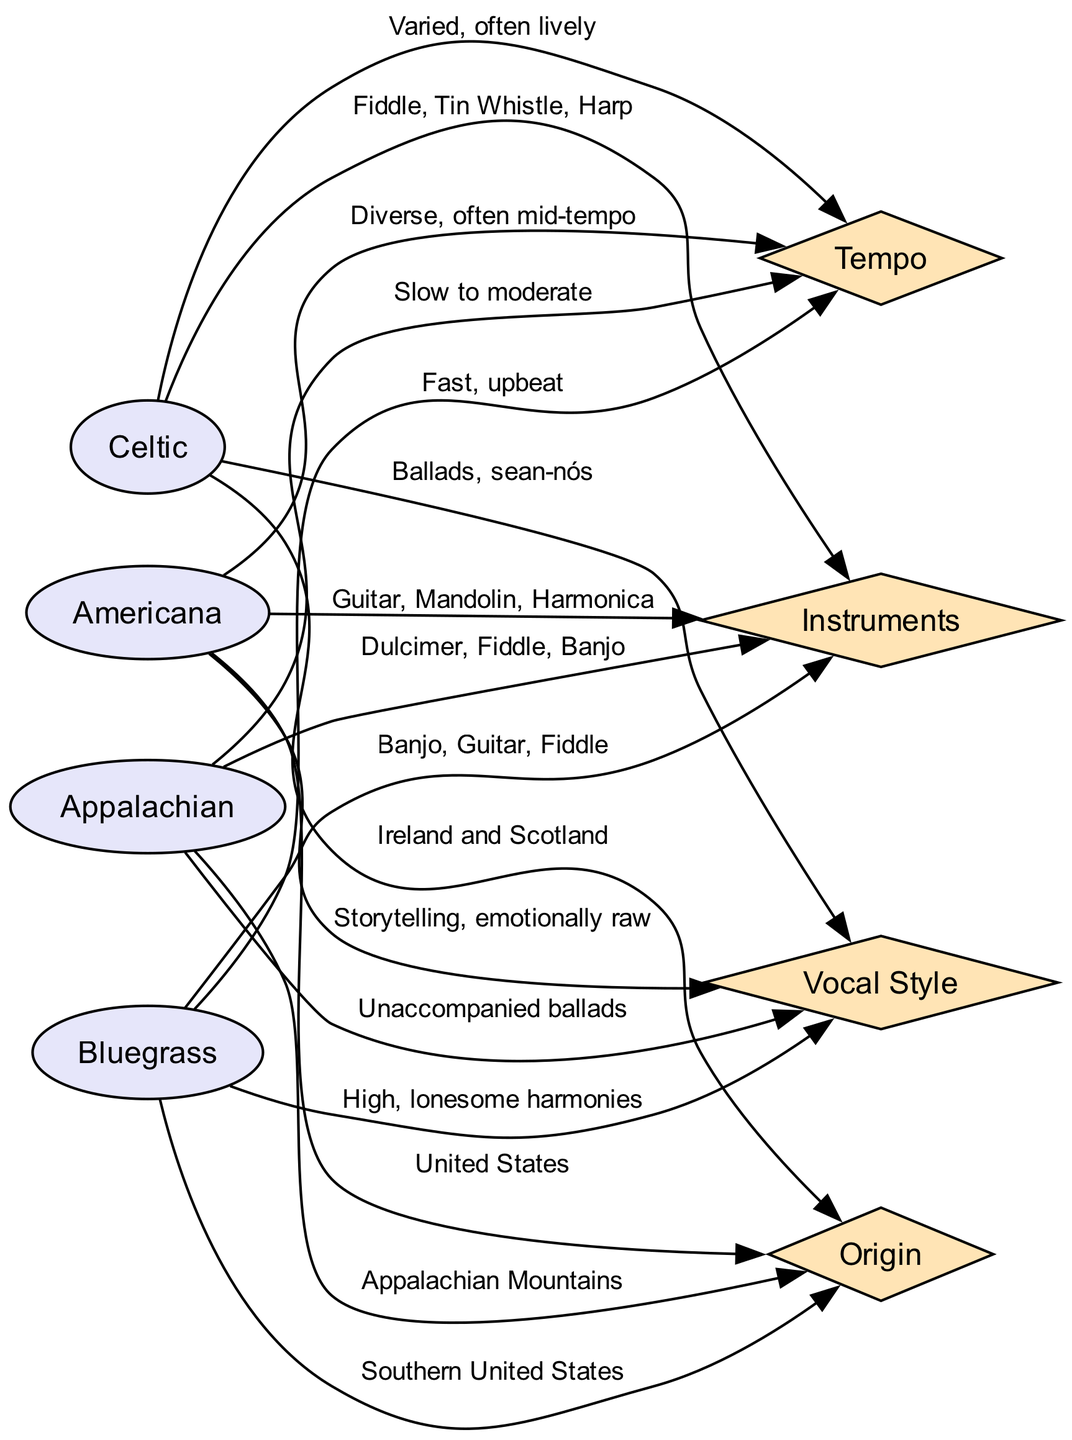What instruments are used in Bluegrass? The diagram shows a direct connection from the "Bluegrass" genre node to the "Instruments" characteristic node. The label on the edge indicates that the instruments used in Bluegrass are "Banjo, Guitar, Fiddle."
Answer: Banjo, Guitar, Fiddle What is the vocal style of Celtic music? The edge connecting the "Celtic" genre node and "Vocal Style" node has a label that states "Ballads, sean-nós." This label directly answers the question regarding the vocal style associated with Celtic music.
Answer: Ballads, sean-nós Which folk music genre has a slow to moderate tempo? To answer this, one must look for the tempo description linked to each genre. The edge between "Appalachian" and "Tempo" reads "Slow to moderate," indicating that this genre has this specific tempo characteristic.
Answer: Appalachian How many genres are listed in the comparison chart? The genres are displayed as nodes connected to their respective characteristics. Counting the individual genre nodes shows there are four: Bluegrass, Celtic, Americana, and Appalachian.
Answer: 4 Which genre originates from the Appalachian Mountains? The edge linking "Appalachian" to "Origin" states "Appalachian Mountains." This directly indicates which genre corresponds to that origin. To find the answer, refer to the origin characteristic for the Appalachian genre.
Answer: Appalachian What is the common instrument shared by both Bluegrass and Appalachian genres? By reviewing the instruments listed for both genres, Bluegrass includes "Banjo, Guitar, Fiddle," and Appalachian includes "Dulcimer, Fiddle, Banjo." The common instrument between them is "Banjo."
Answer: Banjo What is the tempo style associated with Americana music? The edge connecting "Americana" to "Tempo" provides the information needed. The label states that the tempo is "Diverse, often mid-tempo," which describes the rhythmic style of this genre.
Answer: Diverse, often mid-tempo Which two genres use the Fiddle as an instrument? The genres "Bluegrass" and "Appalachian" both list "Fiddle" in their instruments section. The answer is determined by examining the instruments for each genre and identifying the commonality.
Answer: Bluegrass, Appalachian What kind of vocal style is characteristic of Americana? By checking the edge that connects "Americana" to "Vocal Style," we find it states "Storytelling, emotionally raw," indicating the unique style associated with this genre.
Answer: Storytelling, emotionally raw 